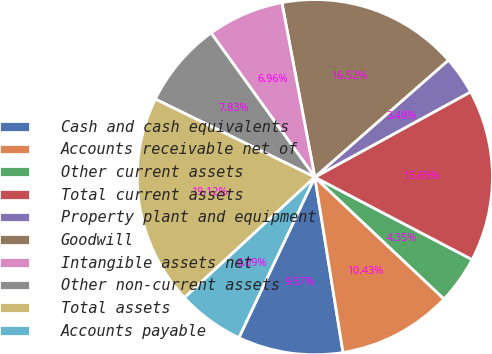<chart> <loc_0><loc_0><loc_500><loc_500><pie_chart><fcel>Cash and cash equivalents<fcel>Accounts receivable net of<fcel>Other current assets<fcel>Total current assets<fcel>Property plant and equipment<fcel>Goodwill<fcel>Intangible assets net<fcel>Other non-current assets<fcel>Total assets<fcel>Accounts payable<nl><fcel>9.57%<fcel>10.43%<fcel>4.35%<fcel>15.65%<fcel>3.48%<fcel>16.52%<fcel>6.96%<fcel>7.83%<fcel>19.12%<fcel>6.09%<nl></chart> 